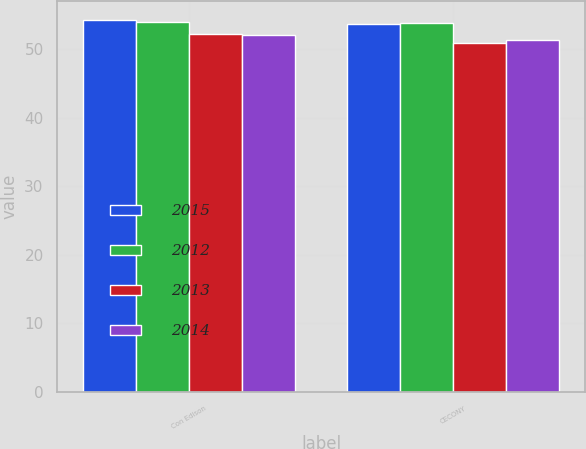<chart> <loc_0><loc_0><loc_500><loc_500><stacked_bar_chart><ecel><fcel>Con Edison<fcel>CECONY<nl><fcel>2015<fcel>54.3<fcel>53.7<nl><fcel>2012<fcel>54<fcel>53.8<nl><fcel>2013<fcel>52.2<fcel>50.9<nl><fcel>2014<fcel>52.1<fcel>51.4<nl></chart> 